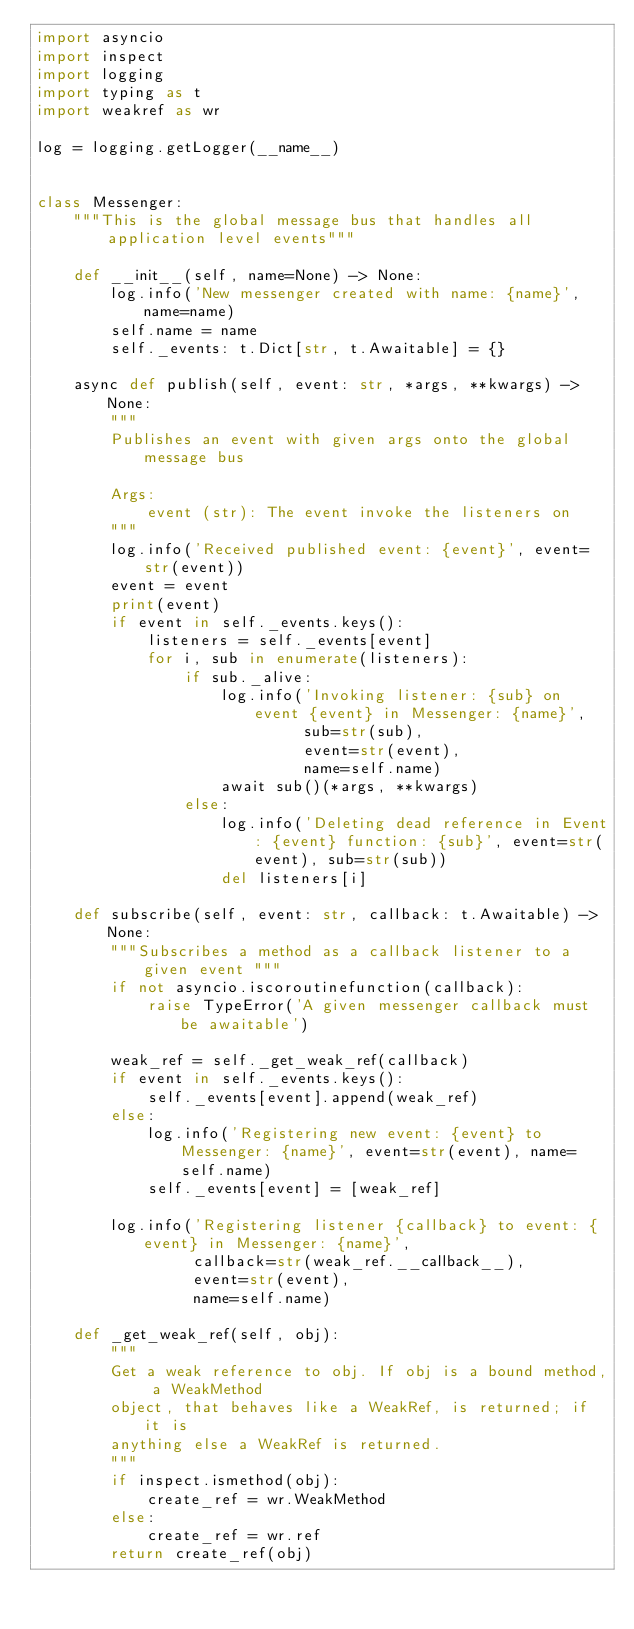<code> <loc_0><loc_0><loc_500><loc_500><_Python_>import asyncio
import inspect
import logging
import typing as t
import weakref as wr

log = logging.getLogger(__name__)


class Messenger:
    """This is the global message bus that handles all application level events"""

    def __init__(self, name=None) -> None:
        log.info('New messenger created with name: {name}', name=name)
        self.name = name
        self._events: t.Dict[str, t.Awaitable] = {}

    async def publish(self, event: str, *args, **kwargs) -> None:
        """
        Publishes an event with given args onto the global message bus

        Args:
            event (str): The event invoke the listeners on
        """
        log.info('Received published event: {event}', event=str(event))
        event = event
        print(event)
        if event in self._events.keys():
            listeners = self._events[event]
            for i, sub in enumerate(listeners):
                if sub._alive:
                    log.info('Invoking listener: {sub} on event {event} in Messenger: {name}',
                             sub=str(sub),
                             event=str(event),
                             name=self.name)
                    await sub()(*args, **kwargs)
                else:
                    log.info('Deleting dead reference in Event: {event} function: {sub}', event=str(event), sub=str(sub))
                    del listeners[i]

    def subscribe(self, event: str, callback: t.Awaitable) -> None:
        """Subscribes a method as a callback listener to a given event """
        if not asyncio.iscoroutinefunction(callback):
            raise TypeError('A given messenger callback must be awaitable')

        weak_ref = self._get_weak_ref(callback)
        if event in self._events.keys():
            self._events[event].append(weak_ref)
        else:
            log.info('Registering new event: {event} to Messenger: {name}', event=str(event), name=self.name)
            self._events[event] = [weak_ref]

        log.info('Registering listener {callback} to event: {event} in Messenger: {name}',
                 callback=str(weak_ref.__callback__),
                 event=str(event),
                 name=self.name)

    def _get_weak_ref(self, obj):
        """
        Get a weak reference to obj. If obj is a bound method, a WeakMethod
        object, that behaves like a WeakRef, is returned; if it is
        anything else a WeakRef is returned.
        """
        if inspect.ismethod(obj):
            create_ref = wr.WeakMethod
        else:
            create_ref = wr.ref
        return create_ref(obj)</code> 